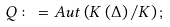<formula> <loc_0><loc_0><loc_500><loc_500>Q \colon = A u t \left ( K \left ( \Delta \right ) / K \right ) ;</formula> 